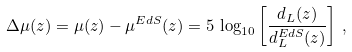<formula> <loc_0><loc_0><loc_500><loc_500>\Delta \mu ( z ) = \mu ( z ) - \mu ^ { E d S } ( z ) = 5 \, \log _ { 1 0 } \left [ \frac { d _ { L } ( z ) } { d _ { L } ^ { E d S } ( z ) } \right ] \, ,</formula> 